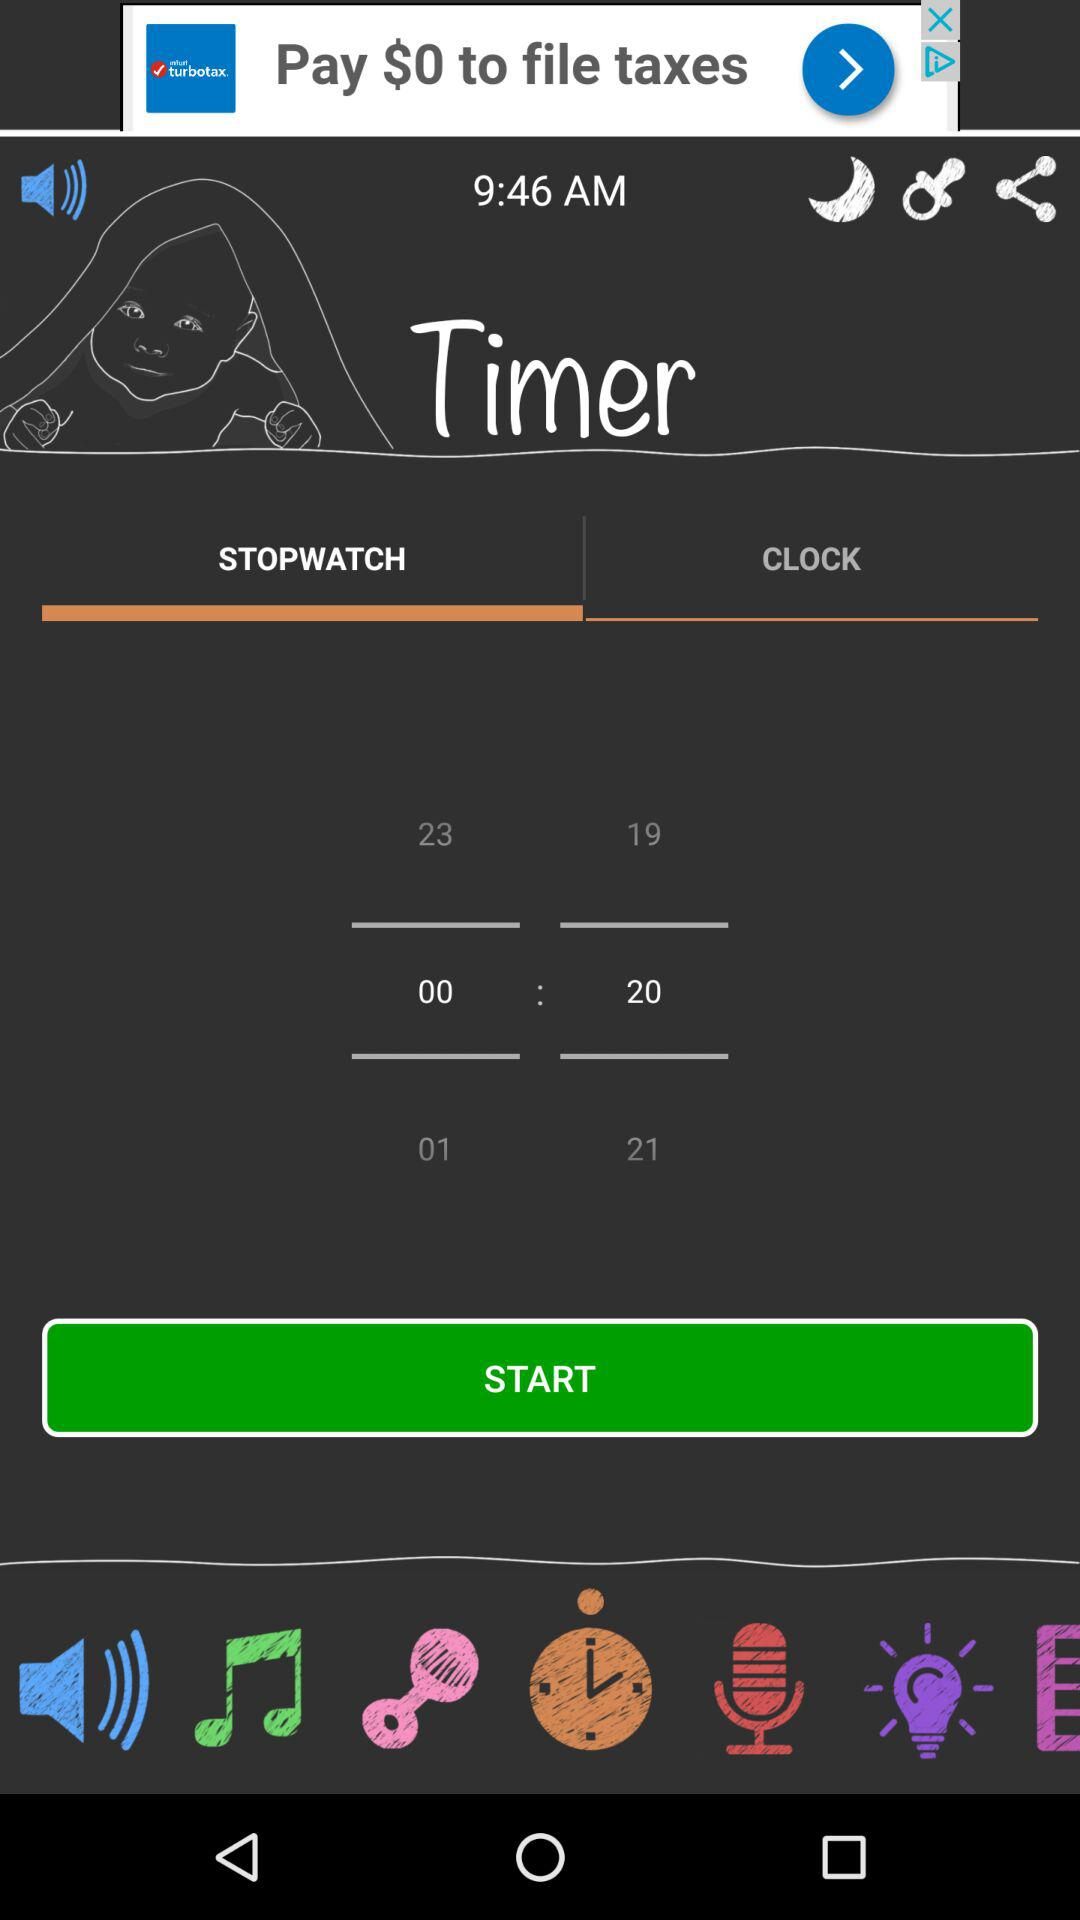What is the time set in the "STOPWATCH"? The time set in the "STOPWATCH" is 00:20. 